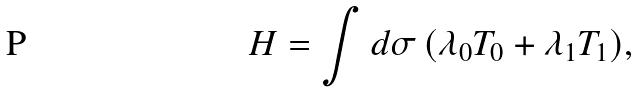<formula> <loc_0><loc_0><loc_500><loc_500>H = \int d \sigma \, ( \lambda _ { 0 } T _ { 0 } + \lambda _ { 1 } T _ { 1 } ) ,</formula> 